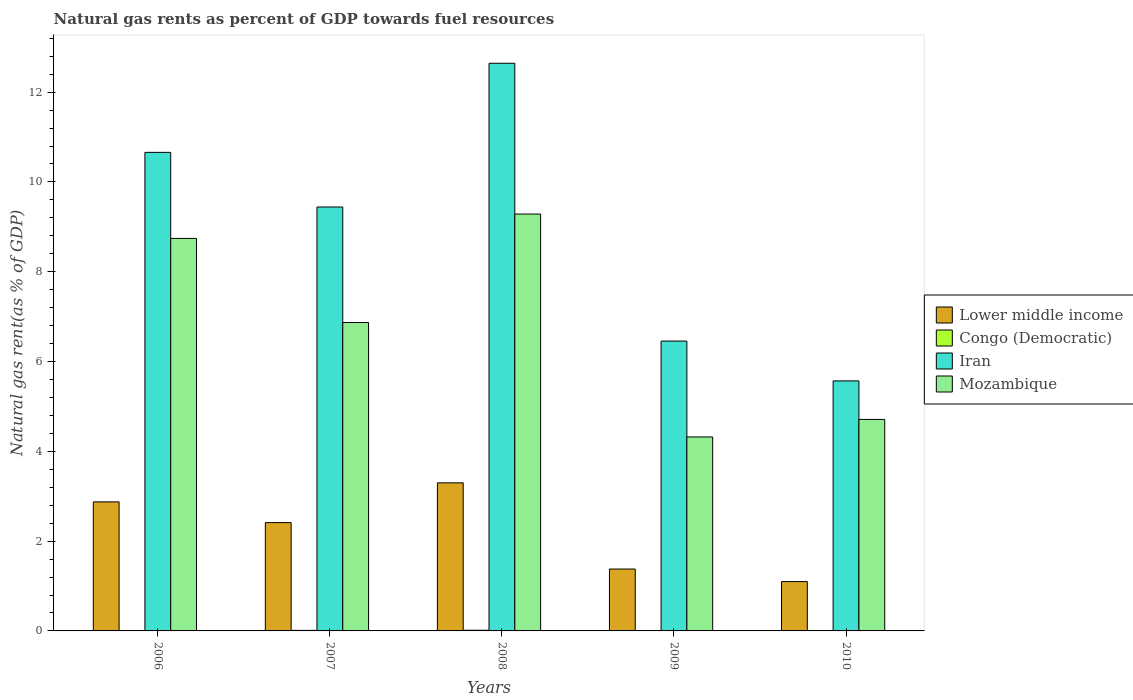How many different coloured bars are there?
Offer a terse response. 4. How many bars are there on the 5th tick from the left?
Your response must be concise. 4. What is the label of the 5th group of bars from the left?
Your answer should be very brief. 2010. In how many cases, is the number of bars for a given year not equal to the number of legend labels?
Keep it short and to the point. 0. What is the natural gas rent in Iran in 2009?
Your response must be concise. 6.46. Across all years, what is the maximum natural gas rent in Mozambique?
Your answer should be very brief. 9.29. Across all years, what is the minimum natural gas rent in Iran?
Your response must be concise. 5.57. In which year was the natural gas rent in Iran maximum?
Ensure brevity in your answer.  2008. What is the total natural gas rent in Mozambique in the graph?
Offer a terse response. 33.93. What is the difference between the natural gas rent in Mozambique in 2007 and that in 2008?
Offer a terse response. -2.42. What is the difference between the natural gas rent in Lower middle income in 2010 and the natural gas rent in Iran in 2009?
Your answer should be very brief. -5.36. What is the average natural gas rent in Congo (Democratic) per year?
Your response must be concise. 0.01. In the year 2008, what is the difference between the natural gas rent in Lower middle income and natural gas rent in Iran?
Offer a very short reply. -9.35. In how many years, is the natural gas rent in Mozambique greater than 3.2 %?
Offer a terse response. 5. What is the ratio of the natural gas rent in Congo (Democratic) in 2007 to that in 2010?
Make the answer very short. 1.97. Is the natural gas rent in Lower middle income in 2007 less than that in 2008?
Give a very brief answer. Yes. Is the difference between the natural gas rent in Lower middle income in 2006 and 2010 greater than the difference between the natural gas rent in Iran in 2006 and 2010?
Ensure brevity in your answer.  No. What is the difference between the highest and the second highest natural gas rent in Congo (Democratic)?
Provide a succinct answer. 0. What is the difference between the highest and the lowest natural gas rent in Mozambique?
Offer a very short reply. 4.96. In how many years, is the natural gas rent in Lower middle income greater than the average natural gas rent in Lower middle income taken over all years?
Provide a succinct answer. 3. What does the 2nd bar from the left in 2006 represents?
Ensure brevity in your answer.  Congo (Democratic). What does the 2nd bar from the right in 2010 represents?
Provide a succinct answer. Iran. Is it the case that in every year, the sum of the natural gas rent in Congo (Democratic) and natural gas rent in Lower middle income is greater than the natural gas rent in Iran?
Ensure brevity in your answer.  No. Are all the bars in the graph horizontal?
Your answer should be compact. No. How many years are there in the graph?
Offer a very short reply. 5. What is the difference between two consecutive major ticks on the Y-axis?
Your response must be concise. 2. Are the values on the major ticks of Y-axis written in scientific E-notation?
Make the answer very short. No. Does the graph contain grids?
Provide a succinct answer. No. Where does the legend appear in the graph?
Provide a succinct answer. Center right. How are the legend labels stacked?
Offer a terse response. Vertical. What is the title of the graph?
Your answer should be compact. Natural gas rents as percent of GDP towards fuel resources. What is the label or title of the X-axis?
Provide a succinct answer. Years. What is the label or title of the Y-axis?
Make the answer very short. Natural gas rent(as % of GDP). What is the Natural gas rent(as % of GDP) of Lower middle income in 2006?
Your answer should be compact. 2.87. What is the Natural gas rent(as % of GDP) of Congo (Democratic) in 2006?
Keep it short and to the point. 0.01. What is the Natural gas rent(as % of GDP) of Iran in 2006?
Your answer should be compact. 10.66. What is the Natural gas rent(as % of GDP) in Mozambique in 2006?
Offer a terse response. 8.74. What is the Natural gas rent(as % of GDP) of Lower middle income in 2007?
Your answer should be very brief. 2.41. What is the Natural gas rent(as % of GDP) of Congo (Democratic) in 2007?
Offer a very short reply. 0.01. What is the Natural gas rent(as % of GDP) in Iran in 2007?
Keep it short and to the point. 9.44. What is the Natural gas rent(as % of GDP) in Mozambique in 2007?
Offer a terse response. 6.87. What is the Natural gas rent(as % of GDP) of Lower middle income in 2008?
Offer a very short reply. 3.3. What is the Natural gas rent(as % of GDP) in Congo (Democratic) in 2008?
Keep it short and to the point. 0.02. What is the Natural gas rent(as % of GDP) in Iran in 2008?
Provide a succinct answer. 12.64. What is the Natural gas rent(as % of GDP) of Mozambique in 2008?
Ensure brevity in your answer.  9.29. What is the Natural gas rent(as % of GDP) in Lower middle income in 2009?
Offer a very short reply. 1.38. What is the Natural gas rent(as % of GDP) in Congo (Democratic) in 2009?
Keep it short and to the point. 0.01. What is the Natural gas rent(as % of GDP) in Iran in 2009?
Give a very brief answer. 6.46. What is the Natural gas rent(as % of GDP) of Mozambique in 2009?
Offer a terse response. 4.32. What is the Natural gas rent(as % of GDP) of Lower middle income in 2010?
Your answer should be very brief. 1.1. What is the Natural gas rent(as % of GDP) in Congo (Democratic) in 2010?
Ensure brevity in your answer.  0.01. What is the Natural gas rent(as % of GDP) of Iran in 2010?
Your answer should be very brief. 5.57. What is the Natural gas rent(as % of GDP) in Mozambique in 2010?
Offer a very short reply. 4.71. Across all years, what is the maximum Natural gas rent(as % of GDP) in Lower middle income?
Give a very brief answer. 3.3. Across all years, what is the maximum Natural gas rent(as % of GDP) in Congo (Democratic)?
Offer a terse response. 0.02. Across all years, what is the maximum Natural gas rent(as % of GDP) of Iran?
Your answer should be compact. 12.64. Across all years, what is the maximum Natural gas rent(as % of GDP) in Mozambique?
Ensure brevity in your answer.  9.29. Across all years, what is the minimum Natural gas rent(as % of GDP) in Lower middle income?
Provide a short and direct response. 1.1. Across all years, what is the minimum Natural gas rent(as % of GDP) of Congo (Democratic)?
Offer a terse response. 0.01. Across all years, what is the minimum Natural gas rent(as % of GDP) of Iran?
Provide a short and direct response. 5.57. Across all years, what is the minimum Natural gas rent(as % of GDP) of Mozambique?
Make the answer very short. 4.32. What is the total Natural gas rent(as % of GDP) in Lower middle income in the graph?
Your answer should be very brief. 11.06. What is the total Natural gas rent(as % of GDP) of Congo (Democratic) in the graph?
Ensure brevity in your answer.  0.05. What is the total Natural gas rent(as % of GDP) in Iran in the graph?
Provide a succinct answer. 44.77. What is the total Natural gas rent(as % of GDP) in Mozambique in the graph?
Offer a very short reply. 33.93. What is the difference between the Natural gas rent(as % of GDP) in Lower middle income in 2006 and that in 2007?
Offer a very short reply. 0.46. What is the difference between the Natural gas rent(as % of GDP) of Congo (Democratic) in 2006 and that in 2007?
Give a very brief answer. -0.01. What is the difference between the Natural gas rent(as % of GDP) in Iran in 2006 and that in 2007?
Your response must be concise. 1.22. What is the difference between the Natural gas rent(as % of GDP) in Mozambique in 2006 and that in 2007?
Provide a short and direct response. 1.87. What is the difference between the Natural gas rent(as % of GDP) of Lower middle income in 2006 and that in 2008?
Keep it short and to the point. -0.42. What is the difference between the Natural gas rent(as % of GDP) in Congo (Democratic) in 2006 and that in 2008?
Your answer should be compact. -0.01. What is the difference between the Natural gas rent(as % of GDP) of Iran in 2006 and that in 2008?
Your answer should be very brief. -1.98. What is the difference between the Natural gas rent(as % of GDP) in Mozambique in 2006 and that in 2008?
Provide a short and direct response. -0.54. What is the difference between the Natural gas rent(as % of GDP) in Lower middle income in 2006 and that in 2009?
Your answer should be compact. 1.5. What is the difference between the Natural gas rent(as % of GDP) in Congo (Democratic) in 2006 and that in 2009?
Make the answer very short. -0. What is the difference between the Natural gas rent(as % of GDP) in Iran in 2006 and that in 2009?
Keep it short and to the point. 4.2. What is the difference between the Natural gas rent(as % of GDP) of Mozambique in 2006 and that in 2009?
Offer a terse response. 4.42. What is the difference between the Natural gas rent(as % of GDP) in Lower middle income in 2006 and that in 2010?
Offer a terse response. 1.78. What is the difference between the Natural gas rent(as % of GDP) of Congo (Democratic) in 2006 and that in 2010?
Provide a succinct answer. 0. What is the difference between the Natural gas rent(as % of GDP) in Iran in 2006 and that in 2010?
Offer a very short reply. 5.09. What is the difference between the Natural gas rent(as % of GDP) of Mozambique in 2006 and that in 2010?
Ensure brevity in your answer.  4.03. What is the difference between the Natural gas rent(as % of GDP) in Lower middle income in 2007 and that in 2008?
Provide a succinct answer. -0.89. What is the difference between the Natural gas rent(as % of GDP) in Congo (Democratic) in 2007 and that in 2008?
Offer a terse response. -0. What is the difference between the Natural gas rent(as % of GDP) of Iran in 2007 and that in 2008?
Your answer should be compact. -3.2. What is the difference between the Natural gas rent(as % of GDP) in Mozambique in 2007 and that in 2008?
Keep it short and to the point. -2.42. What is the difference between the Natural gas rent(as % of GDP) in Lower middle income in 2007 and that in 2009?
Provide a short and direct response. 1.03. What is the difference between the Natural gas rent(as % of GDP) in Congo (Democratic) in 2007 and that in 2009?
Keep it short and to the point. 0. What is the difference between the Natural gas rent(as % of GDP) in Iran in 2007 and that in 2009?
Offer a very short reply. 2.99. What is the difference between the Natural gas rent(as % of GDP) in Mozambique in 2007 and that in 2009?
Make the answer very short. 2.55. What is the difference between the Natural gas rent(as % of GDP) of Lower middle income in 2007 and that in 2010?
Provide a succinct answer. 1.31. What is the difference between the Natural gas rent(as % of GDP) in Congo (Democratic) in 2007 and that in 2010?
Keep it short and to the point. 0.01. What is the difference between the Natural gas rent(as % of GDP) of Iran in 2007 and that in 2010?
Provide a short and direct response. 3.87. What is the difference between the Natural gas rent(as % of GDP) of Mozambique in 2007 and that in 2010?
Make the answer very short. 2.16. What is the difference between the Natural gas rent(as % of GDP) of Lower middle income in 2008 and that in 2009?
Provide a succinct answer. 1.92. What is the difference between the Natural gas rent(as % of GDP) of Congo (Democratic) in 2008 and that in 2009?
Provide a short and direct response. 0.01. What is the difference between the Natural gas rent(as % of GDP) of Iran in 2008 and that in 2009?
Your response must be concise. 6.19. What is the difference between the Natural gas rent(as % of GDP) in Mozambique in 2008 and that in 2009?
Your answer should be compact. 4.96. What is the difference between the Natural gas rent(as % of GDP) in Lower middle income in 2008 and that in 2010?
Your answer should be very brief. 2.2. What is the difference between the Natural gas rent(as % of GDP) in Congo (Democratic) in 2008 and that in 2010?
Provide a short and direct response. 0.01. What is the difference between the Natural gas rent(as % of GDP) of Iran in 2008 and that in 2010?
Your response must be concise. 7.07. What is the difference between the Natural gas rent(as % of GDP) of Mozambique in 2008 and that in 2010?
Provide a succinct answer. 4.57. What is the difference between the Natural gas rent(as % of GDP) of Lower middle income in 2009 and that in 2010?
Your answer should be very brief. 0.28. What is the difference between the Natural gas rent(as % of GDP) of Congo (Democratic) in 2009 and that in 2010?
Keep it short and to the point. 0. What is the difference between the Natural gas rent(as % of GDP) of Iran in 2009 and that in 2010?
Keep it short and to the point. 0.89. What is the difference between the Natural gas rent(as % of GDP) in Mozambique in 2009 and that in 2010?
Make the answer very short. -0.39. What is the difference between the Natural gas rent(as % of GDP) of Lower middle income in 2006 and the Natural gas rent(as % of GDP) of Congo (Democratic) in 2007?
Ensure brevity in your answer.  2.86. What is the difference between the Natural gas rent(as % of GDP) of Lower middle income in 2006 and the Natural gas rent(as % of GDP) of Iran in 2007?
Your answer should be very brief. -6.57. What is the difference between the Natural gas rent(as % of GDP) in Lower middle income in 2006 and the Natural gas rent(as % of GDP) in Mozambique in 2007?
Provide a succinct answer. -3.99. What is the difference between the Natural gas rent(as % of GDP) of Congo (Democratic) in 2006 and the Natural gas rent(as % of GDP) of Iran in 2007?
Make the answer very short. -9.44. What is the difference between the Natural gas rent(as % of GDP) in Congo (Democratic) in 2006 and the Natural gas rent(as % of GDP) in Mozambique in 2007?
Give a very brief answer. -6.86. What is the difference between the Natural gas rent(as % of GDP) of Iran in 2006 and the Natural gas rent(as % of GDP) of Mozambique in 2007?
Make the answer very short. 3.79. What is the difference between the Natural gas rent(as % of GDP) of Lower middle income in 2006 and the Natural gas rent(as % of GDP) of Congo (Democratic) in 2008?
Your answer should be very brief. 2.86. What is the difference between the Natural gas rent(as % of GDP) in Lower middle income in 2006 and the Natural gas rent(as % of GDP) in Iran in 2008?
Keep it short and to the point. -9.77. What is the difference between the Natural gas rent(as % of GDP) in Lower middle income in 2006 and the Natural gas rent(as % of GDP) in Mozambique in 2008?
Keep it short and to the point. -6.41. What is the difference between the Natural gas rent(as % of GDP) in Congo (Democratic) in 2006 and the Natural gas rent(as % of GDP) in Iran in 2008?
Your answer should be compact. -12.64. What is the difference between the Natural gas rent(as % of GDP) in Congo (Democratic) in 2006 and the Natural gas rent(as % of GDP) in Mozambique in 2008?
Offer a very short reply. -9.28. What is the difference between the Natural gas rent(as % of GDP) in Iran in 2006 and the Natural gas rent(as % of GDP) in Mozambique in 2008?
Your response must be concise. 1.37. What is the difference between the Natural gas rent(as % of GDP) of Lower middle income in 2006 and the Natural gas rent(as % of GDP) of Congo (Democratic) in 2009?
Provide a short and direct response. 2.87. What is the difference between the Natural gas rent(as % of GDP) in Lower middle income in 2006 and the Natural gas rent(as % of GDP) in Iran in 2009?
Offer a terse response. -3.58. What is the difference between the Natural gas rent(as % of GDP) of Lower middle income in 2006 and the Natural gas rent(as % of GDP) of Mozambique in 2009?
Provide a short and direct response. -1.45. What is the difference between the Natural gas rent(as % of GDP) in Congo (Democratic) in 2006 and the Natural gas rent(as % of GDP) in Iran in 2009?
Offer a very short reply. -6.45. What is the difference between the Natural gas rent(as % of GDP) of Congo (Democratic) in 2006 and the Natural gas rent(as % of GDP) of Mozambique in 2009?
Offer a terse response. -4.31. What is the difference between the Natural gas rent(as % of GDP) in Iran in 2006 and the Natural gas rent(as % of GDP) in Mozambique in 2009?
Offer a very short reply. 6.34. What is the difference between the Natural gas rent(as % of GDP) of Lower middle income in 2006 and the Natural gas rent(as % of GDP) of Congo (Democratic) in 2010?
Your response must be concise. 2.87. What is the difference between the Natural gas rent(as % of GDP) of Lower middle income in 2006 and the Natural gas rent(as % of GDP) of Iran in 2010?
Your answer should be compact. -2.69. What is the difference between the Natural gas rent(as % of GDP) of Lower middle income in 2006 and the Natural gas rent(as % of GDP) of Mozambique in 2010?
Provide a short and direct response. -1.84. What is the difference between the Natural gas rent(as % of GDP) in Congo (Democratic) in 2006 and the Natural gas rent(as % of GDP) in Iran in 2010?
Ensure brevity in your answer.  -5.56. What is the difference between the Natural gas rent(as % of GDP) of Congo (Democratic) in 2006 and the Natural gas rent(as % of GDP) of Mozambique in 2010?
Your answer should be very brief. -4.7. What is the difference between the Natural gas rent(as % of GDP) of Iran in 2006 and the Natural gas rent(as % of GDP) of Mozambique in 2010?
Provide a short and direct response. 5.95. What is the difference between the Natural gas rent(as % of GDP) of Lower middle income in 2007 and the Natural gas rent(as % of GDP) of Congo (Democratic) in 2008?
Make the answer very short. 2.4. What is the difference between the Natural gas rent(as % of GDP) of Lower middle income in 2007 and the Natural gas rent(as % of GDP) of Iran in 2008?
Ensure brevity in your answer.  -10.23. What is the difference between the Natural gas rent(as % of GDP) of Lower middle income in 2007 and the Natural gas rent(as % of GDP) of Mozambique in 2008?
Your answer should be compact. -6.87. What is the difference between the Natural gas rent(as % of GDP) of Congo (Democratic) in 2007 and the Natural gas rent(as % of GDP) of Iran in 2008?
Offer a very short reply. -12.63. What is the difference between the Natural gas rent(as % of GDP) of Congo (Democratic) in 2007 and the Natural gas rent(as % of GDP) of Mozambique in 2008?
Your response must be concise. -9.27. What is the difference between the Natural gas rent(as % of GDP) of Iran in 2007 and the Natural gas rent(as % of GDP) of Mozambique in 2008?
Provide a short and direct response. 0.16. What is the difference between the Natural gas rent(as % of GDP) in Lower middle income in 2007 and the Natural gas rent(as % of GDP) in Congo (Democratic) in 2009?
Offer a terse response. 2.4. What is the difference between the Natural gas rent(as % of GDP) of Lower middle income in 2007 and the Natural gas rent(as % of GDP) of Iran in 2009?
Ensure brevity in your answer.  -4.04. What is the difference between the Natural gas rent(as % of GDP) in Lower middle income in 2007 and the Natural gas rent(as % of GDP) in Mozambique in 2009?
Make the answer very short. -1.91. What is the difference between the Natural gas rent(as % of GDP) in Congo (Democratic) in 2007 and the Natural gas rent(as % of GDP) in Iran in 2009?
Provide a succinct answer. -6.44. What is the difference between the Natural gas rent(as % of GDP) of Congo (Democratic) in 2007 and the Natural gas rent(as % of GDP) of Mozambique in 2009?
Provide a short and direct response. -4.31. What is the difference between the Natural gas rent(as % of GDP) of Iran in 2007 and the Natural gas rent(as % of GDP) of Mozambique in 2009?
Provide a short and direct response. 5.12. What is the difference between the Natural gas rent(as % of GDP) in Lower middle income in 2007 and the Natural gas rent(as % of GDP) in Congo (Democratic) in 2010?
Offer a very short reply. 2.41. What is the difference between the Natural gas rent(as % of GDP) in Lower middle income in 2007 and the Natural gas rent(as % of GDP) in Iran in 2010?
Your answer should be compact. -3.16. What is the difference between the Natural gas rent(as % of GDP) of Lower middle income in 2007 and the Natural gas rent(as % of GDP) of Mozambique in 2010?
Keep it short and to the point. -2.3. What is the difference between the Natural gas rent(as % of GDP) of Congo (Democratic) in 2007 and the Natural gas rent(as % of GDP) of Iran in 2010?
Your answer should be compact. -5.56. What is the difference between the Natural gas rent(as % of GDP) in Congo (Democratic) in 2007 and the Natural gas rent(as % of GDP) in Mozambique in 2010?
Offer a terse response. -4.7. What is the difference between the Natural gas rent(as % of GDP) of Iran in 2007 and the Natural gas rent(as % of GDP) of Mozambique in 2010?
Provide a short and direct response. 4.73. What is the difference between the Natural gas rent(as % of GDP) of Lower middle income in 2008 and the Natural gas rent(as % of GDP) of Congo (Democratic) in 2009?
Your response must be concise. 3.29. What is the difference between the Natural gas rent(as % of GDP) in Lower middle income in 2008 and the Natural gas rent(as % of GDP) in Iran in 2009?
Your response must be concise. -3.16. What is the difference between the Natural gas rent(as % of GDP) of Lower middle income in 2008 and the Natural gas rent(as % of GDP) of Mozambique in 2009?
Offer a very short reply. -1.02. What is the difference between the Natural gas rent(as % of GDP) in Congo (Democratic) in 2008 and the Natural gas rent(as % of GDP) in Iran in 2009?
Keep it short and to the point. -6.44. What is the difference between the Natural gas rent(as % of GDP) of Congo (Democratic) in 2008 and the Natural gas rent(as % of GDP) of Mozambique in 2009?
Your response must be concise. -4.31. What is the difference between the Natural gas rent(as % of GDP) of Iran in 2008 and the Natural gas rent(as % of GDP) of Mozambique in 2009?
Your response must be concise. 8.32. What is the difference between the Natural gas rent(as % of GDP) of Lower middle income in 2008 and the Natural gas rent(as % of GDP) of Congo (Democratic) in 2010?
Keep it short and to the point. 3.29. What is the difference between the Natural gas rent(as % of GDP) in Lower middle income in 2008 and the Natural gas rent(as % of GDP) in Iran in 2010?
Make the answer very short. -2.27. What is the difference between the Natural gas rent(as % of GDP) of Lower middle income in 2008 and the Natural gas rent(as % of GDP) of Mozambique in 2010?
Your answer should be compact. -1.41. What is the difference between the Natural gas rent(as % of GDP) in Congo (Democratic) in 2008 and the Natural gas rent(as % of GDP) in Iran in 2010?
Your answer should be compact. -5.55. What is the difference between the Natural gas rent(as % of GDP) of Congo (Democratic) in 2008 and the Natural gas rent(as % of GDP) of Mozambique in 2010?
Provide a short and direct response. -4.7. What is the difference between the Natural gas rent(as % of GDP) of Iran in 2008 and the Natural gas rent(as % of GDP) of Mozambique in 2010?
Keep it short and to the point. 7.93. What is the difference between the Natural gas rent(as % of GDP) of Lower middle income in 2009 and the Natural gas rent(as % of GDP) of Congo (Democratic) in 2010?
Offer a very short reply. 1.37. What is the difference between the Natural gas rent(as % of GDP) of Lower middle income in 2009 and the Natural gas rent(as % of GDP) of Iran in 2010?
Your answer should be very brief. -4.19. What is the difference between the Natural gas rent(as % of GDP) of Lower middle income in 2009 and the Natural gas rent(as % of GDP) of Mozambique in 2010?
Ensure brevity in your answer.  -3.33. What is the difference between the Natural gas rent(as % of GDP) in Congo (Democratic) in 2009 and the Natural gas rent(as % of GDP) in Iran in 2010?
Your answer should be compact. -5.56. What is the difference between the Natural gas rent(as % of GDP) of Congo (Democratic) in 2009 and the Natural gas rent(as % of GDP) of Mozambique in 2010?
Keep it short and to the point. -4.7. What is the difference between the Natural gas rent(as % of GDP) of Iran in 2009 and the Natural gas rent(as % of GDP) of Mozambique in 2010?
Make the answer very short. 1.75. What is the average Natural gas rent(as % of GDP) of Lower middle income per year?
Ensure brevity in your answer.  2.21. What is the average Natural gas rent(as % of GDP) of Congo (Democratic) per year?
Keep it short and to the point. 0.01. What is the average Natural gas rent(as % of GDP) of Iran per year?
Your answer should be compact. 8.95. What is the average Natural gas rent(as % of GDP) in Mozambique per year?
Your answer should be compact. 6.79. In the year 2006, what is the difference between the Natural gas rent(as % of GDP) in Lower middle income and Natural gas rent(as % of GDP) in Congo (Democratic)?
Your answer should be compact. 2.87. In the year 2006, what is the difference between the Natural gas rent(as % of GDP) in Lower middle income and Natural gas rent(as % of GDP) in Iran?
Provide a succinct answer. -7.78. In the year 2006, what is the difference between the Natural gas rent(as % of GDP) in Lower middle income and Natural gas rent(as % of GDP) in Mozambique?
Give a very brief answer. -5.87. In the year 2006, what is the difference between the Natural gas rent(as % of GDP) in Congo (Democratic) and Natural gas rent(as % of GDP) in Iran?
Provide a succinct answer. -10.65. In the year 2006, what is the difference between the Natural gas rent(as % of GDP) of Congo (Democratic) and Natural gas rent(as % of GDP) of Mozambique?
Your answer should be very brief. -8.74. In the year 2006, what is the difference between the Natural gas rent(as % of GDP) in Iran and Natural gas rent(as % of GDP) in Mozambique?
Your response must be concise. 1.92. In the year 2007, what is the difference between the Natural gas rent(as % of GDP) in Lower middle income and Natural gas rent(as % of GDP) in Congo (Democratic)?
Keep it short and to the point. 2.4. In the year 2007, what is the difference between the Natural gas rent(as % of GDP) in Lower middle income and Natural gas rent(as % of GDP) in Iran?
Offer a very short reply. -7.03. In the year 2007, what is the difference between the Natural gas rent(as % of GDP) in Lower middle income and Natural gas rent(as % of GDP) in Mozambique?
Your response must be concise. -4.46. In the year 2007, what is the difference between the Natural gas rent(as % of GDP) of Congo (Democratic) and Natural gas rent(as % of GDP) of Iran?
Your response must be concise. -9.43. In the year 2007, what is the difference between the Natural gas rent(as % of GDP) in Congo (Democratic) and Natural gas rent(as % of GDP) in Mozambique?
Your response must be concise. -6.86. In the year 2007, what is the difference between the Natural gas rent(as % of GDP) in Iran and Natural gas rent(as % of GDP) in Mozambique?
Offer a very short reply. 2.57. In the year 2008, what is the difference between the Natural gas rent(as % of GDP) in Lower middle income and Natural gas rent(as % of GDP) in Congo (Democratic)?
Keep it short and to the point. 3.28. In the year 2008, what is the difference between the Natural gas rent(as % of GDP) of Lower middle income and Natural gas rent(as % of GDP) of Iran?
Your response must be concise. -9.35. In the year 2008, what is the difference between the Natural gas rent(as % of GDP) in Lower middle income and Natural gas rent(as % of GDP) in Mozambique?
Offer a terse response. -5.99. In the year 2008, what is the difference between the Natural gas rent(as % of GDP) of Congo (Democratic) and Natural gas rent(as % of GDP) of Iran?
Make the answer very short. -12.63. In the year 2008, what is the difference between the Natural gas rent(as % of GDP) of Congo (Democratic) and Natural gas rent(as % of GDP) of Mozambique?
Ensure brevity in your answer.  -9.27. In the year 2008, what is the difference between the Natural gas rent(as % of GDP) in Iran and Natural gas rent(as % of GDP) in Mozambique?
Your response must be concise. 3.36. In the year 2009, what is the difference between the Natural gas rent(as % of GDP) of Lower middle income and Natural gas rent(as % of GDP) of Congo (Democratic)?
Make the answer very short. 1.37. In the year 2009, what is the difference between the Natural gas rent(as % of GDP) in Lower middle income and Natural gas rent(as % of GDP) in Iran?
Ensure brevity in your answer.  -5.08. In the year 2009, what is the difference between the Natural gas rent(as % of GDP) of Lower middle income and Natural gas rent(as % of GDP) of Mozambique?
Give a very brief answer. -2.94. In the year 2009, what is the difference between the Natural gas rent(as % of GDP) in Congo (Democratic) and Natural gas rent(as % of GDP) in Iran?
Offer a very short reply. -6.45. In the year 2009, what is the difference between the Natural gas rent(as % of GDP) in Congo (Democratic) and Natural gas rent(as % of GDP) in Mozambique?
Give a very brief answer. -4.31. In the year 2009, what is the difference between the Natural gas rent(as % of GDP) in Iran and Natural gas rent(as % of GDP) in Mozambique?
Provide a short and direct response. 2.14. In the year 2010, what is the difference between the Natural gas rent(as % of GDP) in Lower middle income and Natural gas rent(as % of GDP) in Congo (Democratic)?
Provide a short and direct response. 1.09. In the year 2010, what is the difference between the Natural gas rent(as % of GDP) of Lower middle income and Natural gas rent(as % of GDP) of Iran?
Keep it short and to the point. -4.47. In the year 2010, what is the difference between the Natural gas rent(as % of GDP) of Lower middle income and Natural gas rent(as % of GDP) of Mozambique?
Make the answer very short. -3.61. In the year 2010, what is the difference between the Natural gas rent(as % of GDP) in Congo (Democratic) and Natural gas rent(as % of GDP) in Iran?
Your answer should be compact. -5.56. In the year 2010, what is the difference between the Natural gas rent(as % of GDP) in Congo (Democratic) and Natural gas rent(as % of GDP) in Mozambique?
Ensure brevity in your answer.  -4.7. In the year 2010, what is the difference between the Natural gas rent(as % of GDP) of Iran and Natural gas rent(as % of GDP) of Mozambique?
Your response must be concise. 0.86. What is the ratio of the Natural gas rent(as % of GDP) in Lower middle income in 2006 to that in 2007?
Your response must be concise. 1.19. What is the ratio of the Natural gas rent(as % of GDP) of Congo (Democratic) in 2006 to that in 2007?
Ensure brevity in your answer.  0.55. What is the ratio of the Natural gas rent(as % of GDP) of Iran in 2006 to that in 2007?
Provide a succinct answer. 1.13. What is the ratio of the Natural gas rent(as % of GDP) of Mozambique in 2006 to that in 2007?
Make the answer very short. 1.27. What is the ratio of the Natural gas rent(as % of GDP) of Lower middle income in 2006 to that in 2008?
Provide a short and direct response. 0.87. What is the ratio of the Natural gas rent(as % of GDP) of Congo (Democratic) in 2006 to that in 2008?
Make the answer very short. 0.44. What is the ratio of the Natural gas rent(as % of GDP) in Iran in 2006 to that in 2008?
Your response must be concise. 0.84. What is the ratio of the Natural gas rent(as % of GDP) in Mozambique in 2006 to that in 2008?
Provide a short and direct response. 0.94. What is the ratio of the Natural gas rent(as % of GDP) of Lower middle income in 2006 to that in 2009?
Provide a short and direct response. 2.09. What is the ratio of the Natural gas rent(as % of GDP) of Congo (Democratic) in 2006 to that in 2009?
Provide a short and direct response. 0.91. What is the ratio of the Natural gas rent(as % of GDP) in Iran in 2006 to that in 2009?
Keep it short and to the point. 1.65. What is the ratio of the Natural gas rent(as % of GDP) in Mozambique in 2006 to that in 2009?
Ensure brevity in your answer.  2.02. What is the ratio of the Natural gas rent(as % of GDP) in Lower middle income in 2006 to that in 2010?
Provide a succinct answer. 2.62. What is the ratio of the Natural gas rent(as % of GDP) of Congo (Democratic) in 2006 to that in 2010?
Your answer should be compact. 1.09. What is the ratio of the Natural gas rent(as % of GDP) in Iran in 2006 to that in 2010?
Give a very brief answer. 1.91. What is the ratio of the Natural gas rent(as % of GDP) in Mozambique in 2006 to that in 2010?
Keep it short and to the point. 1.86. What is the ratio of the Natural gas rent(as % of GDP) of Lower middle income in 2007 to that in 2008?
Keep it short and to the point. 0.73. What is the ratio of the Natural gas rent(as % of GDP) in Congo (Democratic) in 2007 to that in 2008?
Your answer should be compact. 0.8. What is the ratio of the Natural gas rent(as % of GDP) in Iran in 2007 to that in 2008?
Give a very brief answer. 0.75. What is the ratio of the Natural gas rent(as % of GDP) in Mozambique in 2007 to that in 2008?
Offer a very short reply. 0.74. What is the ratio of the Natural gas rent(as % of GDP) of Lower middle income in 2007 to that in 2009?
Keep it short and to the point. 1.75. What is the ratio of the Natural gas rent(as % of GDP) of Congo (Democratic) in 2007 to that in 2009?
Make the answer very short. 1.65. What is the ratio of the Natural gas rent(as % of GDP) of Iran in 2007 to that in 2009?
Your response must be concise. 1.46. What is the ratio of the Natural gas rent(as % of GDP) of Mozambique in 2007 to that in 2009?
Make the answer very short. 1.59. What is the ratio of the Natural gas rent(as % of GDP) in Lower middle income in 2007 to that in 2010?
Give a very brief answer. 2.2. What is the ratio of the Natural gas rent(as % of GDP) of Congo (Democratic) in 2007 to that in 2010?
Offer a very short reply. 1.97. What is the ratio of the Natural gas rent(as % of GDP) in Iran in 2007 to that in 2010?
Your answer should be very brief. 1.7. What is the ratio of the Natural gas rent(as % of GDP) in Mozambique in 2007 to that in 2010?
Offer a terse response. 1.46. What is the ratio of the Natural gas rent(as % of GDP) of Lower middle income in 2008 to that in 2009?
Provide a short and direct response. 2.39. What is the ratio of the Natural gas rent(as % of GDP) in Congo (Democratic) in 2008 to that in 2009?
Provide a short and direct response. 2.06. What is the ratio of the Natural gas rent(as % of GDP) in Iran in 2008 to that in 2009?
Keep it short and to the point. 1.96. What is the ratio of the Natural gas rent(as % of GDP) of Mozambique in 2008 to that in 2009?
Offer a terse response. 2.15. What is the ratio of the Natural gas rent(as % of GDP) of Lower middle income in 2008 to that in 2010?
Make the answer very short. 3. What is the ratio of the Natural gas rent(as % of GDP) of Congo (Democratic) in 2008 to that in 2010?
Provide a succinct answer. 2.46. What is the ratio of the Natural gas rent(as % of GDP) of Iran in 2008 to that in 2010?
Offer a very short reply. 2.27. What is the ratio of the Natural gas rent(as % of GDP) in Mozambique in 2008 to that in 2010?
Offer a very short reply. 1.97. What is the ratio of the Natural gas rent(as % of GDP) of Lower middle income in 2009 to that in 2010?
Your answer should be compact. 1.25. What is the ratio of the Natural gas rent(as % of GDP) in Congo (Democratic) in 2009 to that in 2010?
Keep it short and to the point. 1.2. What is the ratio of the Natural gas rent(as % of GDP) of Iran in 2009 to that in 2010?
Keep it short and to the point. 1.16. What is the ratio of the Natural gas rent(as % of GDP) of Mozambique in 2009 to that in 2010?
Provide a short and direct response. 0.92. What is the difference between the highest and the second highest Natural gas rent(as % of GDP) in Lower middle income?
Provide a short and direct response. 0.42. What is the difference between the highest and the second highest Natural gas rent(as % of GDP) in Congo (Democratic)?
Keep it short and to the point. 0. What is the difference between the highest and the second highest Natural gas rent(as % of GDP) in Iran?
Your response must be concise. 1.98. What is the difference between the highest and the second highest Natural gas rent(as % of GDP) of Mozambique?
Your answer should be very brief. 0.54. What is the difference between the highest and the lowest Natural gas rent(as % of GDP) in Lower middle income?
Offer a very short reply. 2.2. What is the difference between the highest and the lowest Natural gas rent(as % of GDP) of Congo (Democratic)?
Offer a very short reply. 0.01. What is the difference between the highest and the lowest Natural gas rent(as % of GDP) in Iran?
Keep it short and to the point. 7.07. What is the difference between the highest and the lowest Natural gas rent(as % of GDP) of Mozambique?
Give a very brief answer. 4.96. 